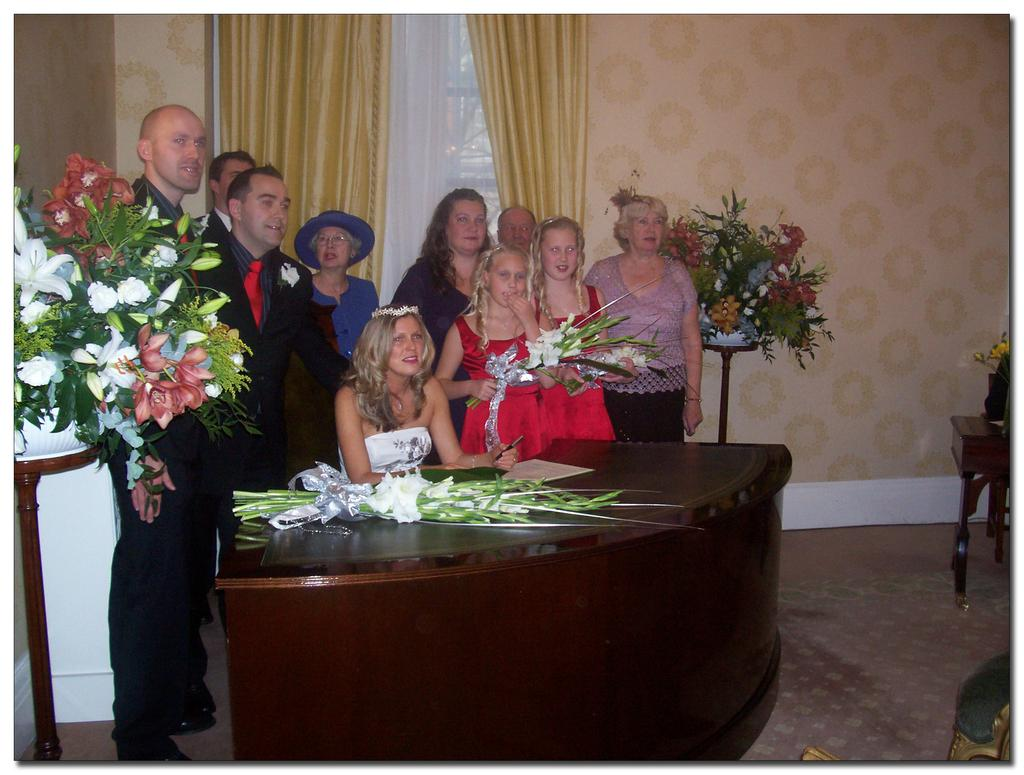Who or what is present in the image? There are people in the image. What are the people doing in the image? The people are standing and posing for a photo. Can you describe the floral elements in the image? There are flowers on both the left and right sides of the image. What type of rod can be seen holding up the soup in the image? There is no rod or soup present in the image. 